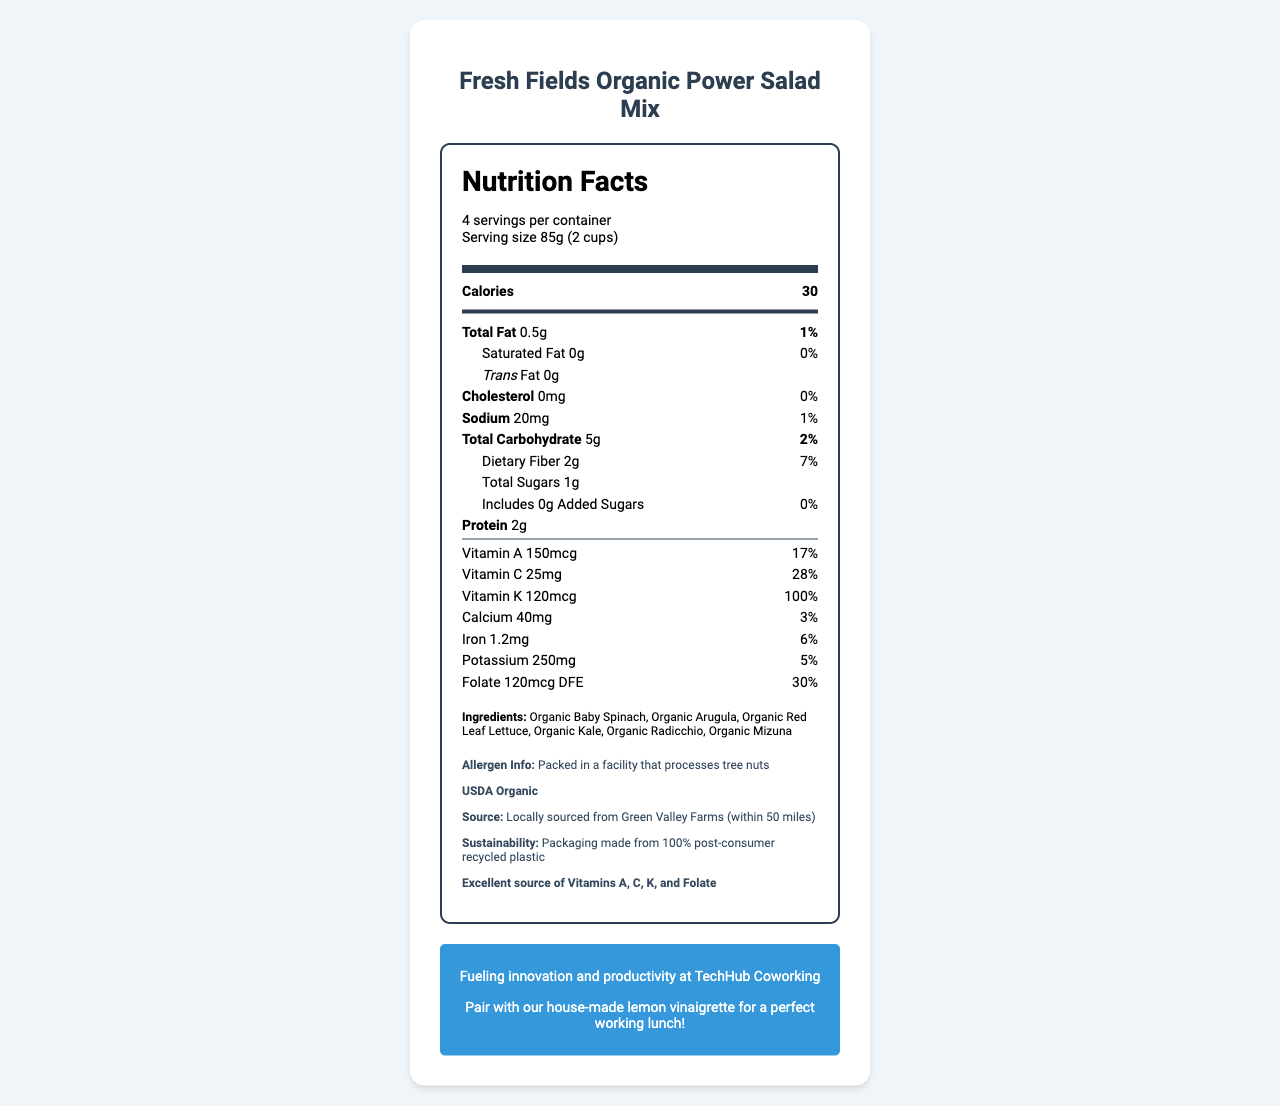who is the product's source? The document states that the product is locally sourced from Green Valley Farms, which is located within 50 miles.
Answer: Green Valley Farms what is the serving size of the salad mix? The document lists the serving size as 85g (2 cups).
Answer: 85g (2 cups) how many calories are there per serving? The nutrition label indicates that there are 30 calories per serving.
Answer: 30 what is the daily value percentage for Vitamin K? The document shows that the Vitamin K content provides 100% of the daily value.
Answer: 100% list the ingredients of the salad mix. The ingredients section lists all these items as part of the salad mix.
Answer: Organic Baby Spinach, Organic Arugula, Organic Red Leaf Lettuce, Organic Kale, Organic Radicchio, Organic Mizuna which vitamin has the highest daily value percentage? A. Vitamin A B. Vitamin C C. Vitamin K D. Folate The daily value percentages are 17% for Vitamin A, 28% for Vitamin C, 100% for Vitamin K, and 30% for Folate. Vitamin K has the highest percentage.
Answer: C. Vitamin K how many grams of protein does one serving contain? The nutrition label indicates that each serving contains 2g of protein.
Answer: 2g is this product USDA Organic? The document confirms that the product is certified USDA Organic.
Answer: Yes does this salad mix contain any added sugars? The document lists "0g" for added sugars.
Answer: No describe the main idea of the document. The document provides extensive details about the Fresh Fields Organic Power Salad Mix, emphasizing its health benefits, organic and local sourcing, and sustainability efforts, along with a promotional note.
Answer: The document is a nutrition facts label for Fresh Fields Organic Power Salad Mix, highlighting its low calorie content and high nutrient values. The label includes detailed nutritional information, ingredients, allergen information, organic certification, source, sustainability facts, and promotional notes for the coworking space's café. what is the salad mix’s packaging made from? The document mentions that the packaging is made from 100% post-consumer recycled plastic.
Answer: 100% post-consumer recycled plastic what is the total fat content per serving, in grams? The nutrition label specifies that the total fat content per serving is 0.5g.
Answer: 0.5g how many servings are there per container? The document states that there are 4 servings per container.
Answer: 4 what is the sodium content per serving, in milligrams? The sodium content per serving is listed as 20mg.
Answer: 20mg is there any cholesterol in the salad mix? The document states that the cholesterol content is 0mg.
Answer: No which of the following is NOT listed as an ingredient? A. Organic Baby Spinach B. Organic Carrots C. Organic Kale D. Organic Mizuna The listed ingredients include Organic Baby Spinach, Organic Arugula, Organic Red Leaf Lettuce, Organic Kale, Organic Radicchio, and Organic Mizuna, but not Organic Carrots.
Answer: B. Organic Carrots where is the salad mix promoted as being utilized? The document has a note stating that the product fuels innovation and productivity at TechHub Coworking.
Answer: TechHub Coworking is the product hazardous due to tree nut allergens? The document indicates that the product is packed in a facility that processes tree nuts, implying a potential allergen risk.
Answer: It may be explain the nutritional benefits of the salad mix. The product offers significant daily values for key vitamins and minerals, contains dietary fiber, and protein, all while maintaining low calories, fat, and sodium, making it a nutritious choice.
Answer: The salad mix provides a low calorie option with a high concentration of essential vitamins and minerals. It is an excellent source of Vitamins A, C, K, and Folate. It also has a decent amount of dietary fiber and protein while containing very low fat and sodium content. who owns Green Valley Farms? The document does not provide information regarding the ownership of Green Valley Farms.
Answer: Cannot be determined 